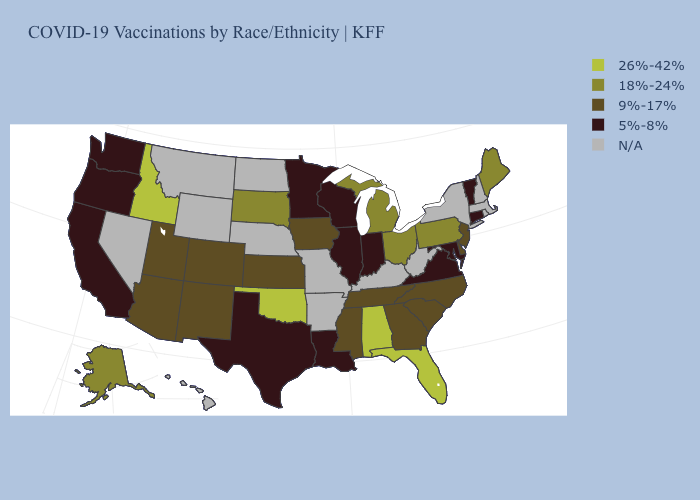Name the states that have a value in the range 9%-17%?
Give a very brief answer. Arizona, Colorado, Delaware, Georgia, Iowa, Kansas, Mississippi, New Jersey, New Mexico, North Carolina, South Carolina, Tennessee, Utah. Which states hav the highest value in the MidWest?
Answer briefly. Michigan, Ohio, South Dakota. Name the states that have a value in the range 18%-24%?
Answer briefly. Alaska, Maine, Michigan, Ohio, Pennsylvania, South Dakota. What is the value of Massachusetts?
Be succinct. N/A. Which states have the lowest value in the USA?
Keep it brief. California, Connecticut, Illinois, Indiana, Louisiana, Maryland, Minnesota, Oregon, Texas, Vermont, Virginia, Washington, Wisconsin. How many symbols are there in the legend?
Quick response, please. 5. What is the highest value in the South ?
Give a very brief answer. 26%-42%. Is the legend a continuous bar?
Give a very brief answer. No. What is the lowest value in the USA?
Concise answer only. 5%-8%. What is the value of Indiana?
Short answer required. 5%-8%. What is the value of California?
Answer briefly. 5%-8%. Name the states that have a value in the range 18%-24%?
Be succinct. Alaska, Maine, Michigan, Ohio, Pennsylvania, South Dakota. What is the value of Minnesota?
Short answer required. 5%-8%. Does Connecticut have the highest value in the Northeast?
Answer briefly. No. Among the states that border Oklahoma , which have the lowest value?
Short answer required. Texas. 